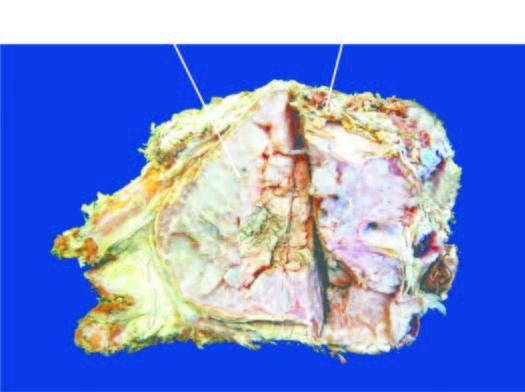does the amputated head of the long bone show lobulated mass with bluish cartilaginous hue infiltrating the soft tissues?
Answer the question using a single word or phrase. No 